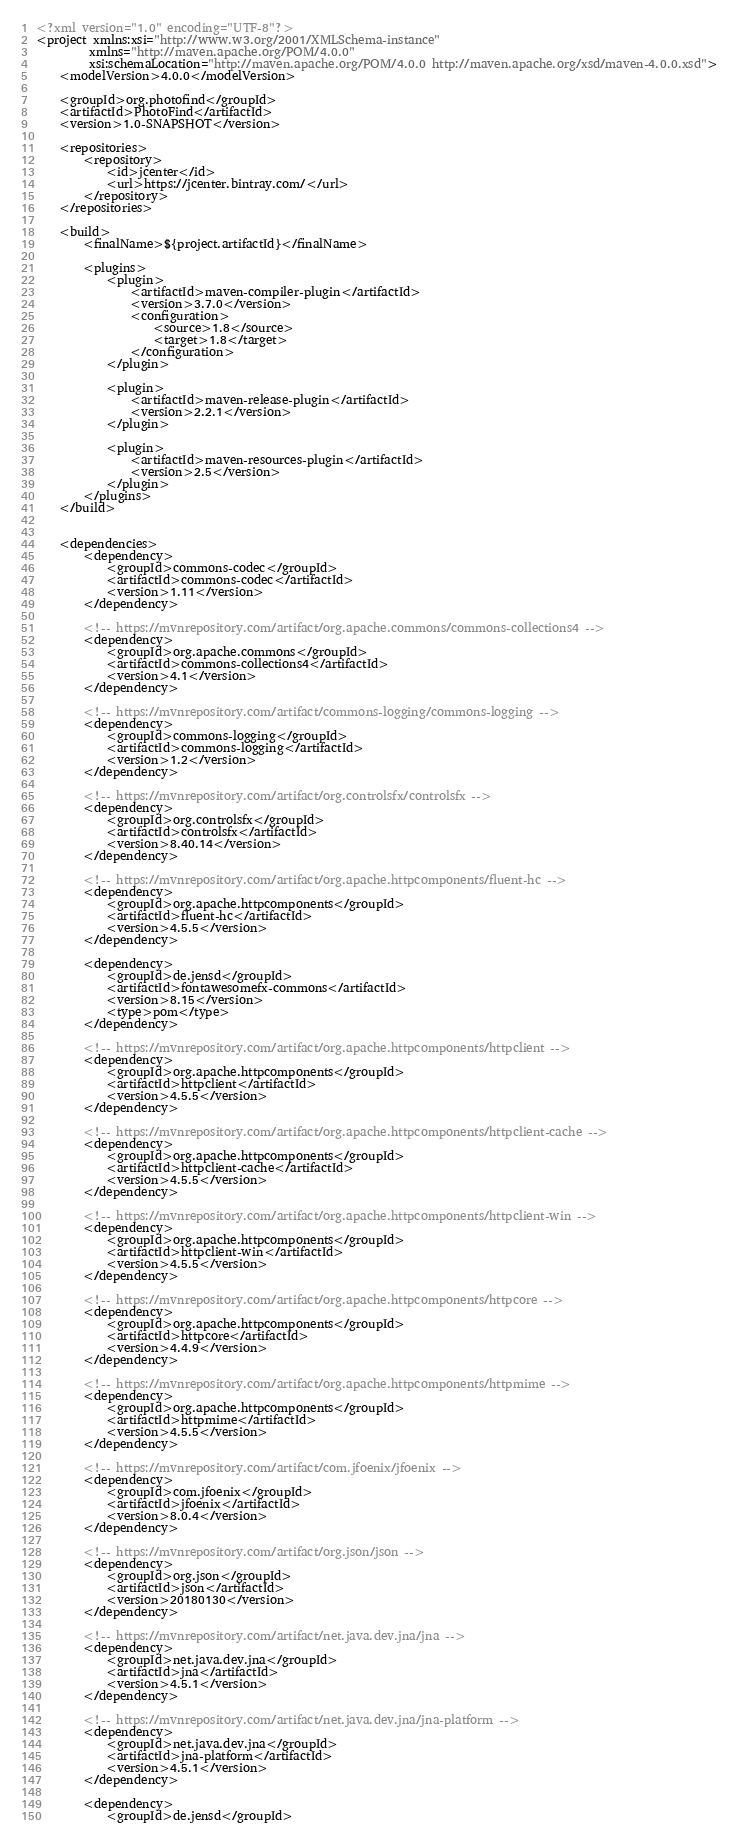<code> <loc_0><loc_0><loc_500><loc_500><_XML_><?xml version="1.0" encoding="UTF-8"?>
<project xmlns:xsi="http://www.w3.org/2001/XMLSchema-instance"
         xmlns="http://maven.apache.org/POM/4.0.0"
         xsi:schemaLocation="http://maven.apache.org/POM/4.0.0 http://maven.apache.org/xsd/maven-4.0.0.xsd">
    <modelVersion>4.0.0</modelVersion>

    <groupId>org.photofind</groupId>
    <artifactId>PhotoFind</artifactId>
    <version>1.0-SNAPSHOT</version>

    <repositories>
        <repository>
            <id>jcenter</id>
            <url>https://jcenter.bintray.com/</url>
        </repository>
    </repositories>

    <build>
        <finalName>${project.artifactId}</finalName>

        <plugins>
            <plugin>
                <artifactId>maven-compiler-plugin</artifactId>
                <version>3.7.0</version>
                <configuration>
                    <source>1.8</source>
                    <target>1.8</target>
                </configuration>
            </plugin>

            <plugin>
                <artifactId>maven-release-plugin</artifactId>
                <version>2.2.1</version>
            </plugin>

            <plugin>
                <artifactId>maven-resources-plugin</artifactId>
                <version>2.5</version>
            </plugin>
        </plugins>
    </build>


    <dependencies>
        <dependency>
            <groupId>commons-codec</groupId>
            <artifactId>commons-codec</artifactId>
            <version>1.11</version>
        </dependency>

        <!-- https://mvnrepository.com/artifact/org.apache.commons/commons-collections4 -->
        <dependency>
            <groupId>org.apache.commons</groupId>
            <artifactId>commons-collections4</artifactId>
            <version>4.1</version>
        </dependency>

        <!-- https://mvnrepository.com/artifact/commons-logging/commons-logging -->
        <dependency>
            <groupId>commons-logging</groupId>
            <artifactId>commons-logging</artifactId>
            <version>1.2</version>
        </dependency>

        <!-- https://mvnrepository.com/artifact/org.controlsfx/controlsfx -->
        <dependency>
            <groupId>org.controlsfx</groupId>
            <artifactId>controlsfx</artifactId>
            <version>8.40.14</version>
        </dependency>

        <!-- https://mvnrepository.com/artifact/org.apache.httpcomponents/fluent-hc -->
        <dependency>
            <groupId>org.apache.httpcomponents</groupId>
            <artifactId>fluent-hc</artifactId>
            <version>4.5.5</version>
        </dependency>

        <dependency>
            <groupId>de.jensd</groupId>
            <artifactId>fontawesomefx-commons</artifactId>
            <version>8.15</version>
            <type>pom</type>
        </dependency>

        <!-- https://mvnrepository.com/artifact/org.apache.httpcomponents/httpclient -->
        <dependency>
            <groupId>org.apache.httpcomponents</groupId>
            <artifactId>httpclient</artifactId>
            <version>4.5.5</version>
        </dependency>

        <!-- https://mvnrepository.com/artifact/org.apache.httpcomponents/httpclient-cache -->
        <dependency>
            <groupId>org.apache.httpcomponents</groupId>
            <artifactId>httpclient-cache</artifactId>
            <version>4.5.5</version>
        </dependency>

        <!-- https://mvnrepository.com/artifact/org.apache.httpcomponents/httpclient-win -->
        <dependency>
            <groupId>org.apache.httpcomponents</groupId>
            <artifactId>httpclient-win</artifactId>
            <version>4.5.5</version>
        </dependency>

        <!-- https://mvnrepository.com/artifact/org.apache.httpcomponents/httpcore -->
        <dependency>
            <groupId>org.apache.httpcomponents</groupId>
            <artifactId>httpcore</artifactId>
            <version>4.4.9</version>
        </dependency>

        <!-- https://mvnrepository.com/artifact/org.apache.httpcomponents/httpmime -->
        <dependency>
            <groupId>org.apache.httpcomponents</groupId>
            <artifactId>httpmime</artifactId>
            <version>4.5.5</version>
        </dependency>

        <!-- https://mvnrepository.com/artifact/com.jfoenix/jfoenix -->
        <dependency>
            <groupId>com.jfoenix</groupId>
            <artifactId>jfoenix</artifactId>
            <version>8.0.4</version>
        </dependency>

        <!-- https://mvnrepository.com/artifact/org.json/json -->
        <dependency>
            <groupId>org.json</groupId>
            <artifactId>json</artifactId>
            <version>20180130</version>
        </dependency>

        <!-- https://mvnrepository.com/artifact/net.java.dev.jna/jna -->
        <dependency>
            <groupId>net.java.dev.jna</groupId>
            <artifactId>jna</artifactId>
            <version>4.5.1</version>
        </dependency>

        <!-- https://mvnrepository.com/artifact/net.java.dev.jna/jna-platform -->
        <dependency>
            <groupId>net.java.dev.jna</groupId>
            <artifactId>jna-platform</artifactId>
            <version>4.5.1</version>
        </dependency>

        <dependency>
            <groupId>de.jensd</groupId></code> 